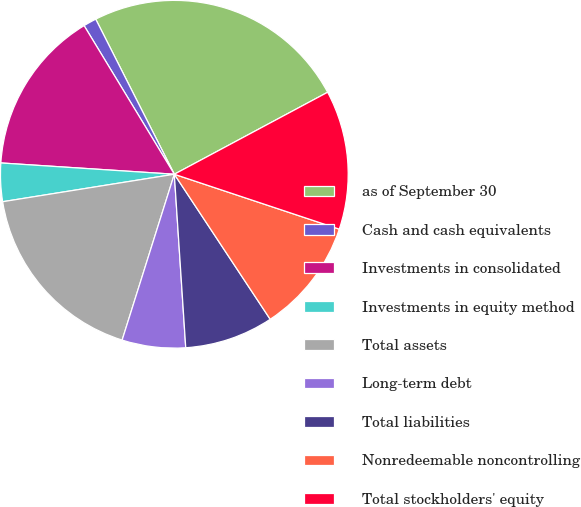Convert chart to OTSL. <chart><loc_0><loc_0><loc_500><loc_500><pie_chart><fcel>as of September 30<fcel>Cash and cash equivalents<fcel>Investments in consolidated<fcel>Investments in equity method<fcel>Total assets<fcel>Long-term debt<fcel>Total liabilities<fcel>Nonredeemable noncontrolling<fcel>Total stockholders' equity<nl><fcel>24.65%<fcel>1.22%<fcel>15.28%<fcel>3.56%<fcel>17.62%<fcel>5.9%<fcel>8.25%<fcel>10.59%<fcel>12.93%<nl></chart> 